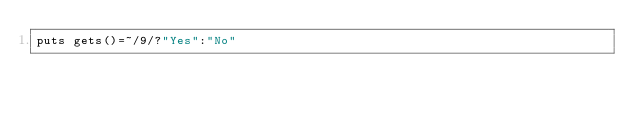Convert code to text. <code><loc_0><loc_0><loc_500><loc_500><_Ruby_>puts gets()=~/9/?"Yes":"No"</code> 